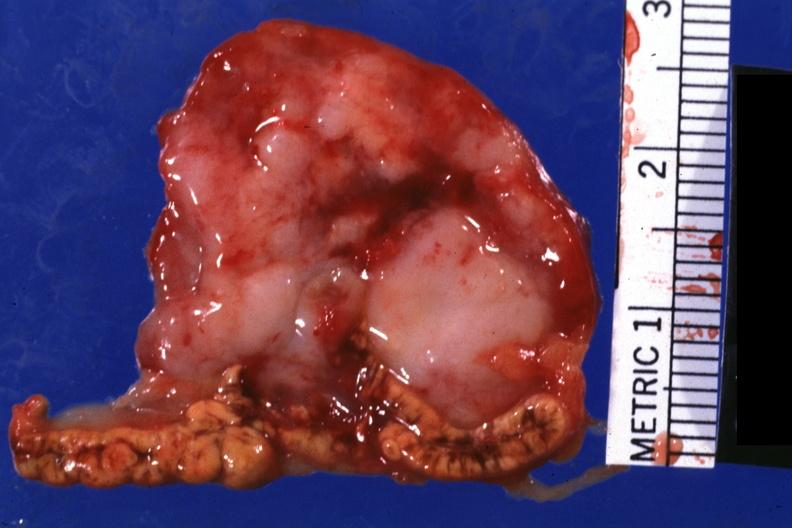s adrenal present?
Answer the question using a single word or phrase. Yes 